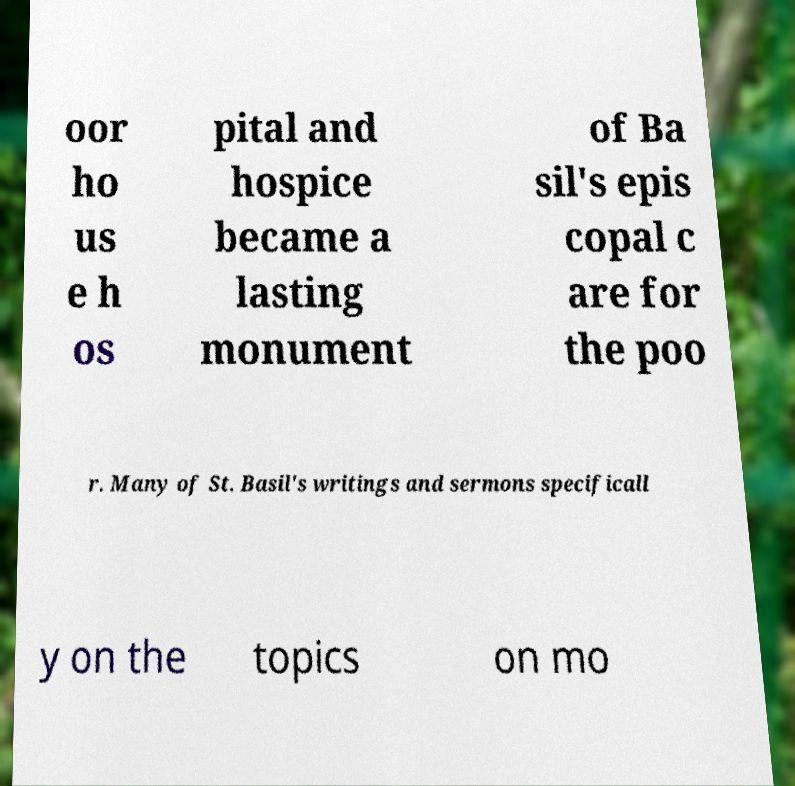For documentation purposes, I need the text within this image transcribed. Could you provide that? oor ho us e h os pital and hospice became a lasting monument of Ba sil's epis copal c are for the poo r. Many of St. Basil's writings and sermons specificall y on the topics on mo 